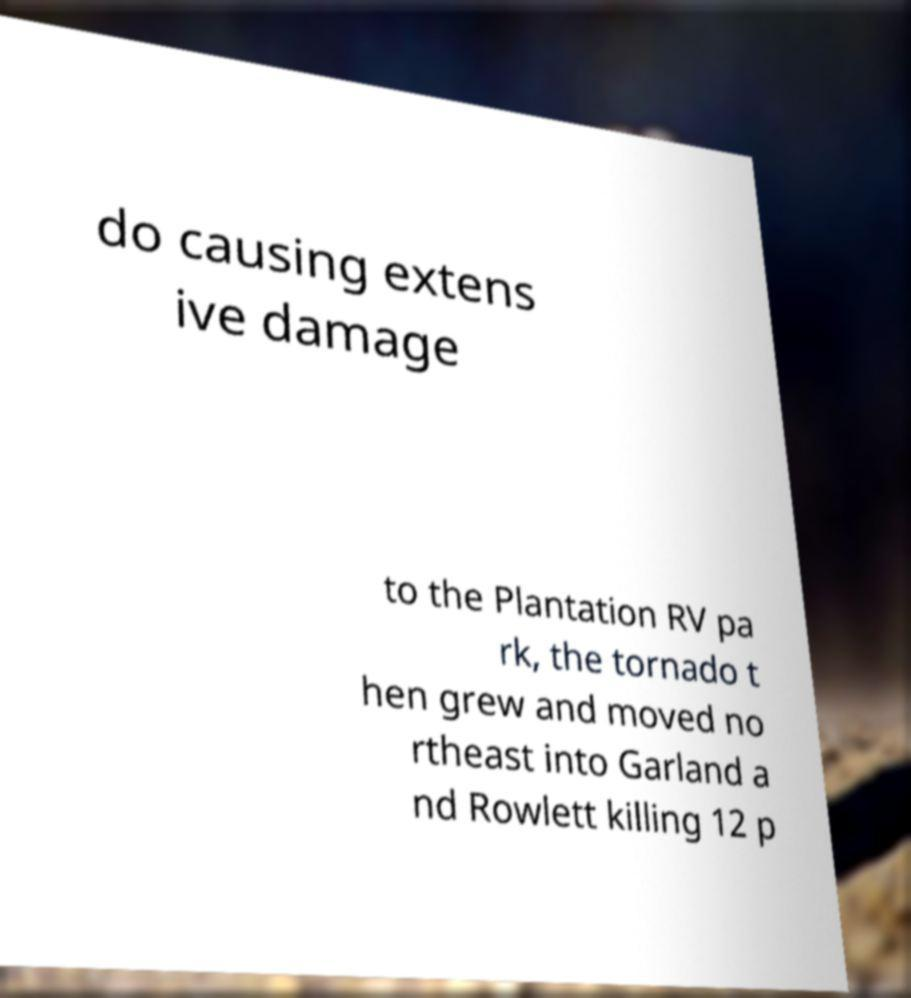Could you extract and type out the text from this image? do causing extens ive damage to the Plantation RV pa rk, the tornado t hen grew and moved no rtheast into Garland a nd Rowlett killing 12 p 